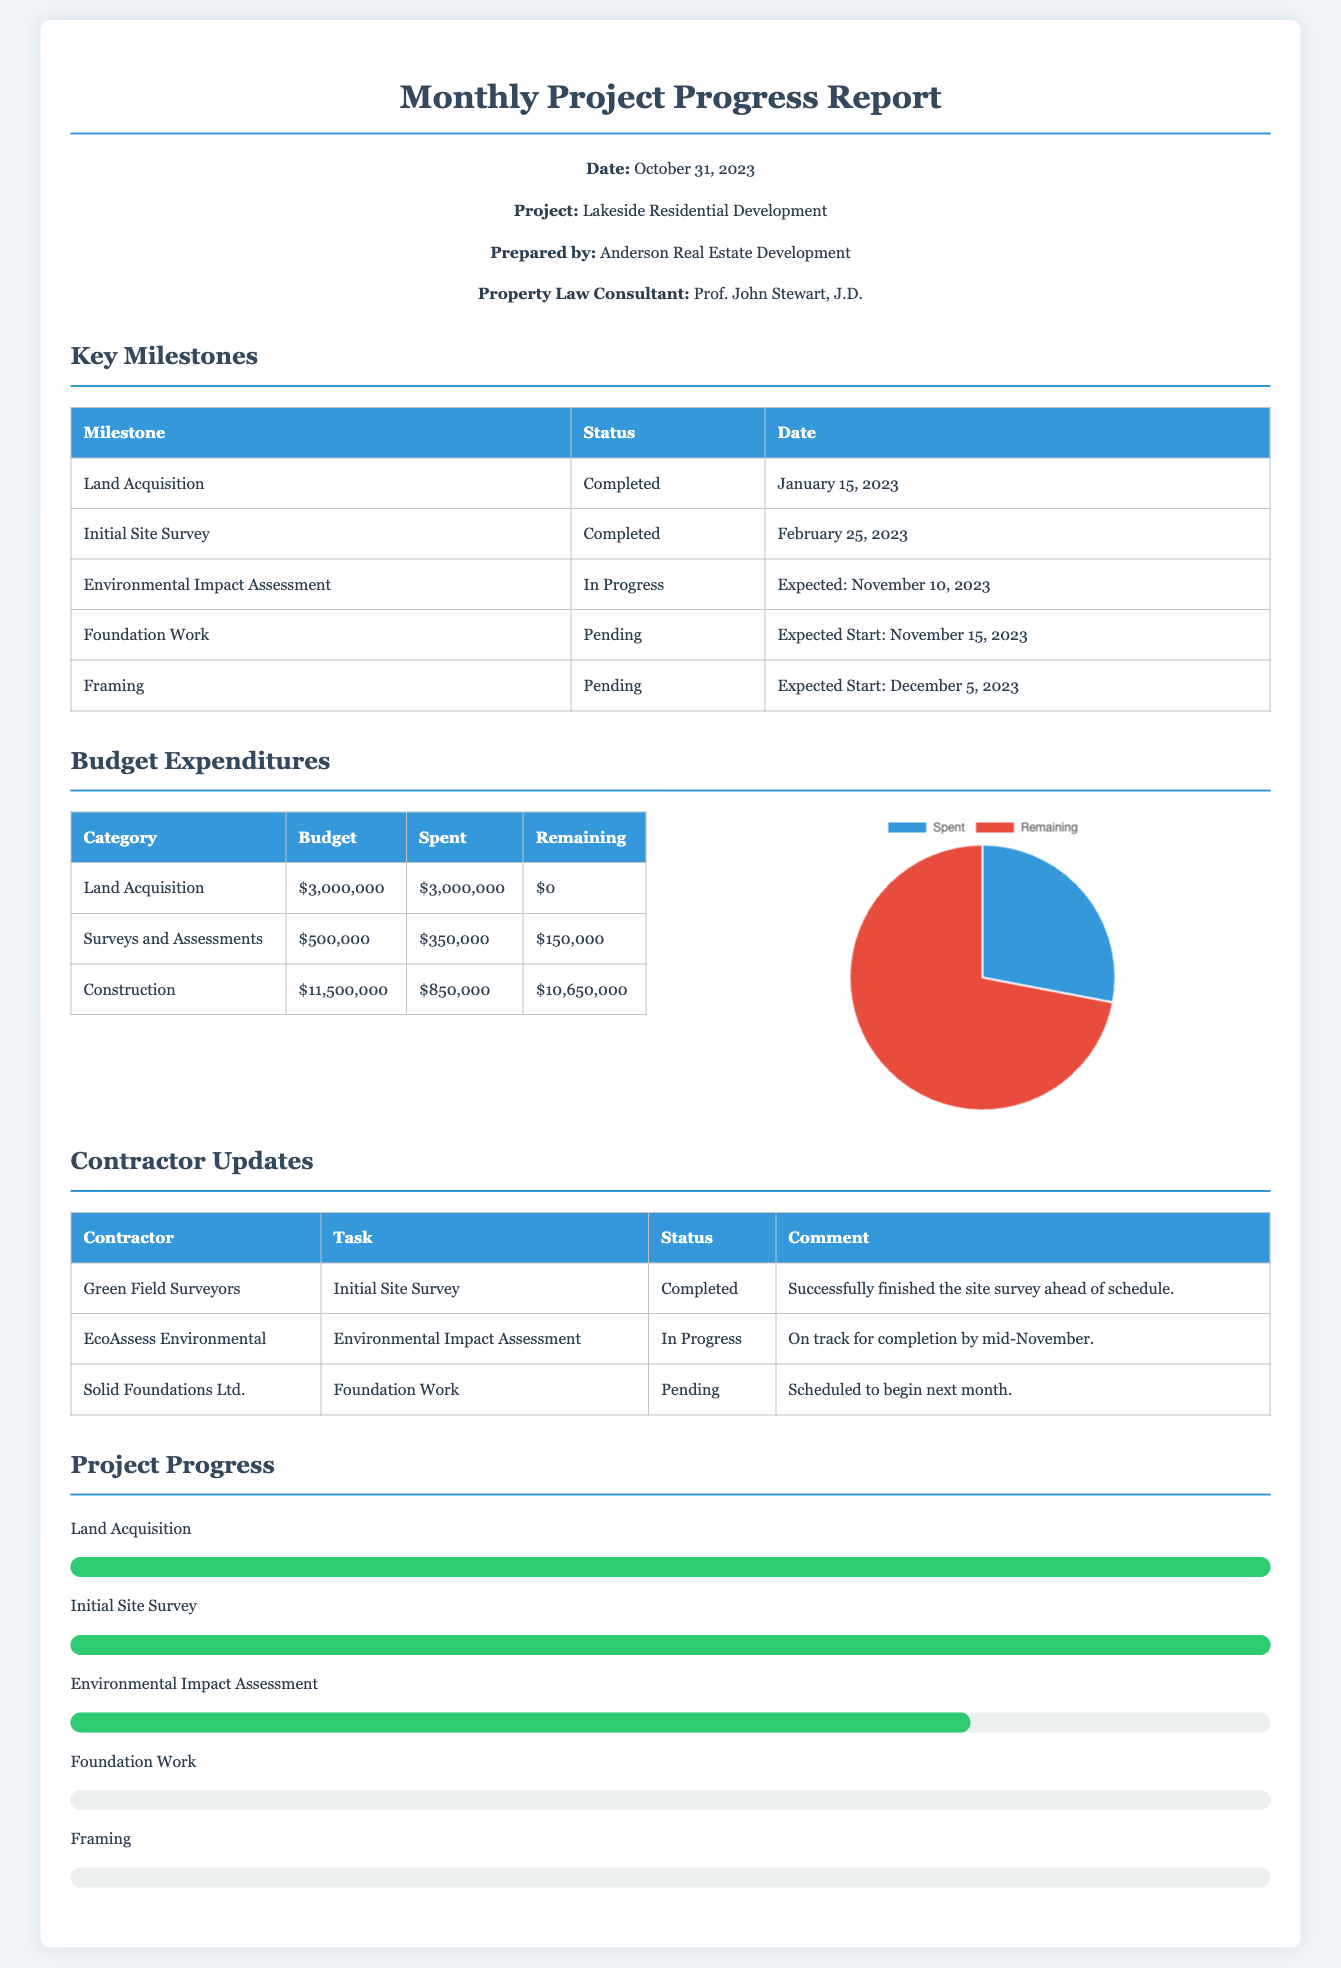What is the project name? The project name is listed in the document header under "Project:".
Answer: Lakeside Residential Development When was the land acquisition completed? The completion date for land acquisition is provided in the "Key Milestones" table.
Answer: January 15, 2023 What is the total budget for construction? The total budget for construction can be found in the "Budget Expenditures" table under the "Construction" category.
Answer: $11,500,000 What percentage of the environmental impact assessment is completed? The progress bar indicates the completion status of the environmental impact assessment in the "Project Progress" section.
Answer: 75% Which contractor is responsible for the initial site survey? The contractor's name for the site survey is shown in the "Contractor Updates" table.
Answer: Green Field Surveyors What is the remaining budget for surveys and assessments? The remaining budget can be calculated from the "Budget Expenditures" table under the "Surveys and Assessments" category.
Answer: $150,000 What is the expected start date for the foundation work? The expected start date is located in the "Key Milestones" table under "Foundation Work".
Answer: November 15, 2023 How many categories are listed under budget expenditures? The number of categories is determined by counting the rows in the "Budget Expenditures" table.
Answer: 3 What type of chart is used to represent budget expenditures? The type of chart is mentioned in the "Budget Expenditures" section and is a graphical representation.
Answer: Pie chart 